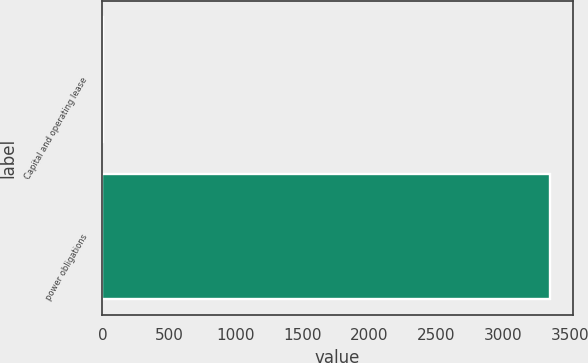<chart> <loc_0><loc_0><loc_500><loc_500><bar_chart><fcel>Capital and operating lease<fcel>power obligations<nl><fcel>1<fcel>3354<nl></chart> 